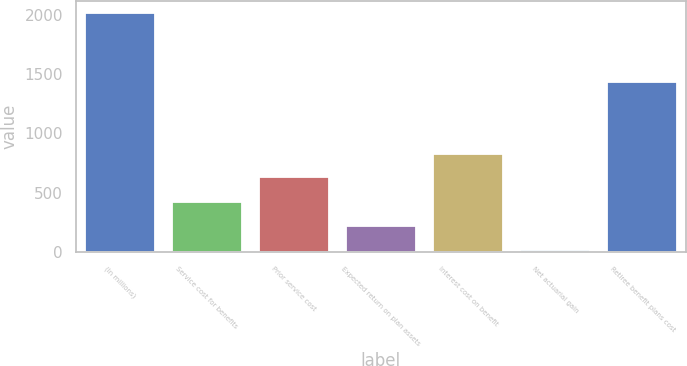<chart> <loc_0><loc_0><loc_500><loc_500><bar_chart><fcel>(In millions)<fcel>Service cost for benefits<fcel>Prior service cost<fcel>Expected return on plan assets<fcel>Interest cost on benefit<fcel>Net actuarial gain<fcel>Retiree benefit plans cost<nl><fcel>2010<fcel>419.6<fcel>631<fcel>220.8<fcel>829.8<fcel>22<fcel>1433<nl></chart> 